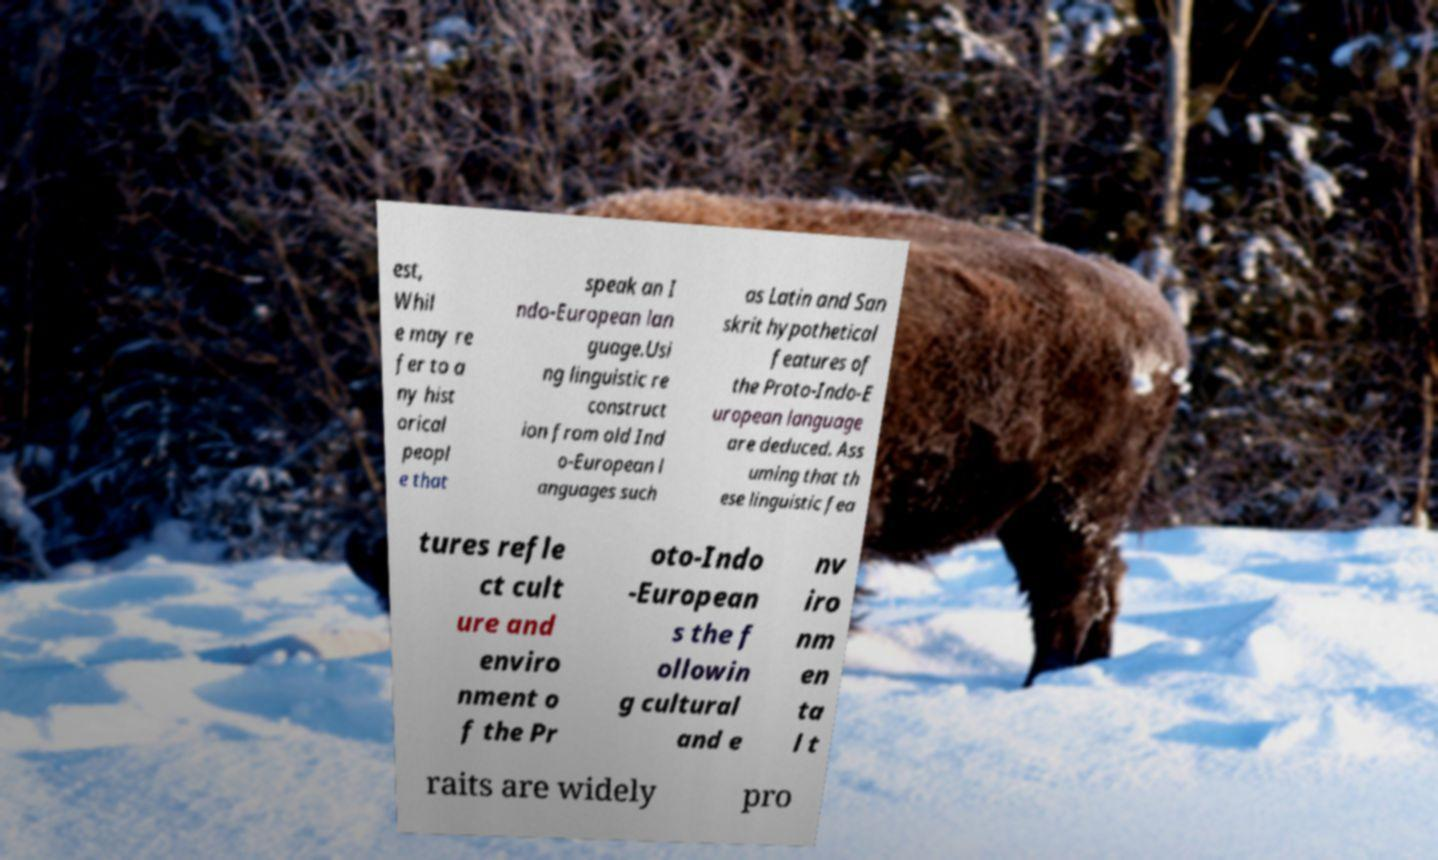Please read and relay the text visible in this image. What does it say? est, Whil e may re fer to a ny hist orical peopl e that speak an I ndo-European lan guage.Usi ng linguistic re construct ion from old Ind o-European l anguages such as Latin and San skrit hypothetical features of the Proto-Indo-E uropean language are deduced. Ass uming that th ese linguistic fea tures refle ct cult ure and enviro nment o f the Pr oto-Indo -European s the f ollowin g cultural and e nv iro nm en ta l t raits are widely pro 